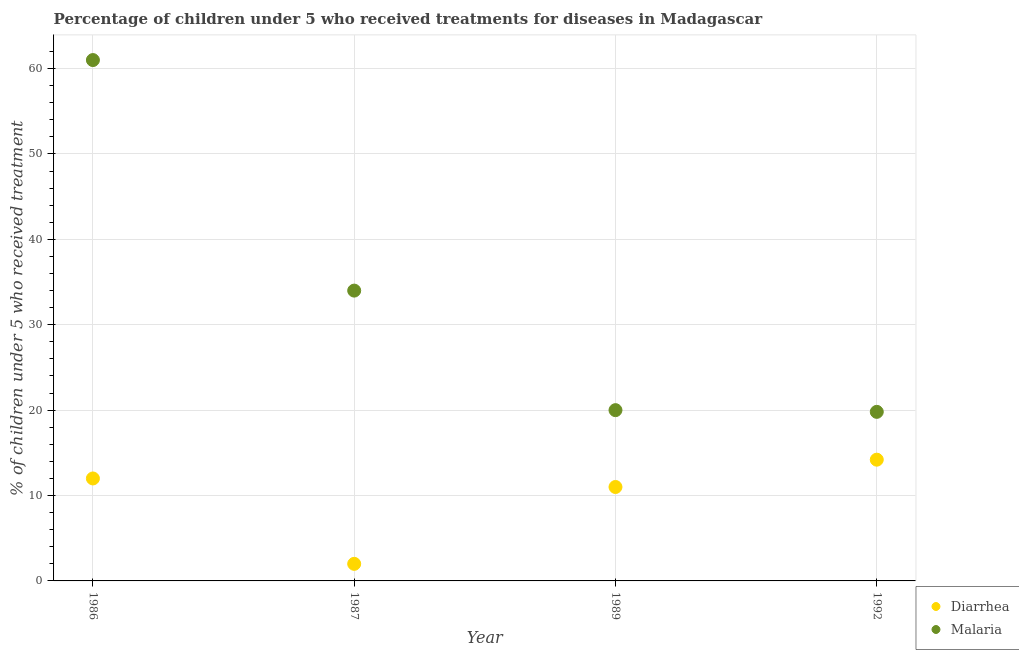What is the percentage of children who received treatment for malaria in 1989?
Offer a very short reply. 20. Across all years, what is the minimum percentage of children who received treatment for malaria?
Give a very brief answer. 19.8. In which year was the percentage of children who received treatment for malaria maximum?
Ensure brevity in your answer.  1986. In which year was the percentage of children who received treatment for diarrhoea minimum?
Offer a terse response. 1987. What is the total percentage of children who received treatment for diarrhoea in the graph?
Your answer should be compact. 39.2. What is the difference between the percentage of children who received treatment for diarrhoea in 1986 and that in 1987?
Offer a terse response. 10. What is the difference between the percentage of children who received treatment for diarrhoea in 1987 and the percentage of children who received treatment for malaria in 1986?
Give a very brief answer. -59. In the year 1986, what is the difference between the percentage of children who received treatment for diarrhoea and percentage of children who received treatment for malaria?
Ensure brevity in your answer.  -49. What is the ratio of the percentage of children who received treatment for diarrhoea in 1986 to that in 1992?
Make the answer very short. 0.85. What is the difference between the highest and the second highest percentage of children who received treatment for malaria?
Make the answer very short. 27. What is the difference between the highest and the lowest percentage of children who received treatment for malaria?
Offer a terse response. 41.2. In how many years, is the percentage of children who received treatment for diarrhoea greater than the average percentage of children who received treatment for diarrhoea taken over all years?
Your response must be concise. 3. Does the percentage of children who received treatment for diarrhoea monotonically increase over the years?
Provide a short and direct response. No. Is the percentage of children who received treatment for diarrhoea strictly greater than the percentage of children who received treatment for malaria over the years?
Make the answer very short. No. Is the percentage of children who received treatment for diarrhoea strictly less than the percentage of children who received treatment for malaria over the years?
Your answer should be compact. Yes. How many years are there in the graph?
Provide a succinct answer. 4. Where does the legend appear in the graph?
Your response must be concise. Bottom right. How many legend labels are there?
Ensure brevity in your answer.  2. How are the legend labels stacked?
Your response must be concise. Vertical. What is the title of the graph?
Give a very brief answer. Percentage of children under 5 who received treatments for diseases in Madagascar. What is the label or title of the Y-axis?
Keep it short and to the point. % of children under 5 who received treatment. What is the % of children under 5 who received treatment of Malaria in 1986?
Your answer should be very brief. 61. What is the % of children under 5 who received treatment of Diarrhea in 1987?
Your answer should be compact. 2. What is the % of children under 5 who received treatment of Malaria in 1987?
Your answer should be very brief. 34. What is the % of children under 5 who received treatment in Diarrhea in 1989?
Your answer should be very brief. 11. What is the % of children under 5 who received treatment in Malaria in 1989?
Your answer should be very brief. 20. What is the % of children under 5 who received treatment of Diarrhea in 1992?
Make the answer very short. 14.2. What is the % of children under 5 who received treatment of Malaria in 1992?
Make the answer very short. 19.8. Across all years, what is the minimum % of children under 5 who received treatment in Malaria?
Make the answer very short. 19.8. What is the total % of children under 5 who received treatment of Diarrhea in the graph?
Offer a very short reply. 39.2. What is the total % of children under 5 who received treatment in Malaria in the graph?
Keep it short and to the point. 134.8. What is the difference between the % of children under 5 who received treatment of Malaria in 1986 and that in 1989?
Your answer should be compact. 41. What is the difference between the % of children under 5 who received treatment in Malaria in 1986 and that in 1992?
Make the answer very short. 41.2. What is the difference between the % of children under 5 who received treatment of Diarrhea in 1987 and that in 1989?
Keep it short and to the point. -9. What is the difference between the % of children under 5 who received treatment of Malaria in 1987 and that in 1989?
Offer a terse response. 14. What is the difference between the % of children under 5 who received treatment in Malaria in 1987 and that in 1992?
Your answer should be very brief. 14.2. What is the difference between the % of children under 5 who received treatment in Diarrhea in 1989 and that in 1992?
Provide a short and direct response. -3.2. What is the difference between the % of children under 5 who received treatment in Diarrhea in 1986 and the % of children under 5 who received treatment in Malaria in 1989?
Your response must be concise. -8. What is the difference between the % of children under 5 who received treatment in Diarrhea in 1987 and the % of children under 5 who received treatment in Malaria in 1992?
Give a very brief answer. -17.8. What is the difference between the % of children under 5 who received treatment of Diarrhea in 1989 and the % of children under 5 who received treatment of Malaria in 1992?
Your answer should be very brief. -8.8. What is the average % of children under 5 who received treatment of Diarrhea per year?
Provide a short and direct response. 9.8. What is the average % of children under 5 who received treatment in Malaria per year?
Make the answer very short. 33.7. In the year 1986, what is the difference between the % of children under 5 who received treatment in Diarrhea and % of children under 5 who received treatment in Malaria?
Your answer should be compact. -49. In the year 1987, what is the difference between the % of children under 5 who received treatment in Diarrhea and % of children under 5 who received treatment in Malaria?
Offer a terse response. -32. In the year 1989, what is the difference between the % of children under 5 who received treatment of Diarrhea and % of children under 5 who received treatment of Malaria?
Provide a succinct answer. -9. In the year 1992, what is the difference between the % of children under 5 who received treatment of Diarrhea and % of children under 5 who received treatment of Malaria?
Ensure brevity in your answer.  -5.6. What is the ratio of the % of children under 5 who received treatment of Diarrhea in 1986 to that in 1987?
Make the answer very short. 6. What is the ratio of the % of children under 5 who received treatment of Malaria in 1986 to that in 1987?
Provide a succinct answer. 1.79. What is the ratio of the % of children under 5 who received treatment of Malaria in 1986 to that in 1989?
Your answer should be compact. 3.05. What is the ratio of the % of children under 5 who received treatment in Diarrhea in 1986 to that in 1992?
Your response must be concise. 0.85. What is the ratio of the % of children under 5 who received treatment of Malaria in 1986 to that in 1992?
Offer a very short reply. 3.08. What is the ratio of the % of children under 5 who received treatment in Diarrhea in 1987 to that in 1989?
Ensure brevity in your answer.  0.18. What is the ratio of the % of children under 5 who received treatment in Malaria in 1987 to that in 1989?
Provide a succinct answer. 1.7. What is the ratio of the % of children under 5 who received treatment in Diarrhea in 1987 to that in 1992?
Your answer should be very brief. 0.14. What is the ratio of the % of children under 5 who received treatment of Malaria in 1987 to that in 1992?
Your answer should be compact. 1.72. What is the ratio of the % of children under 5 who received treatment in Diarrhea in 1989 to that in 1992?
Offer a terse response. 0.77. What is the difference between the highest and the second highest % of children under 5 who received treatment of Malaria?
Ensure brevity in your answer.  27. What is the difference between the highest and the lowest % of children under 5 who received treatment in Malaria?
Make the answer very short. 41.2. 